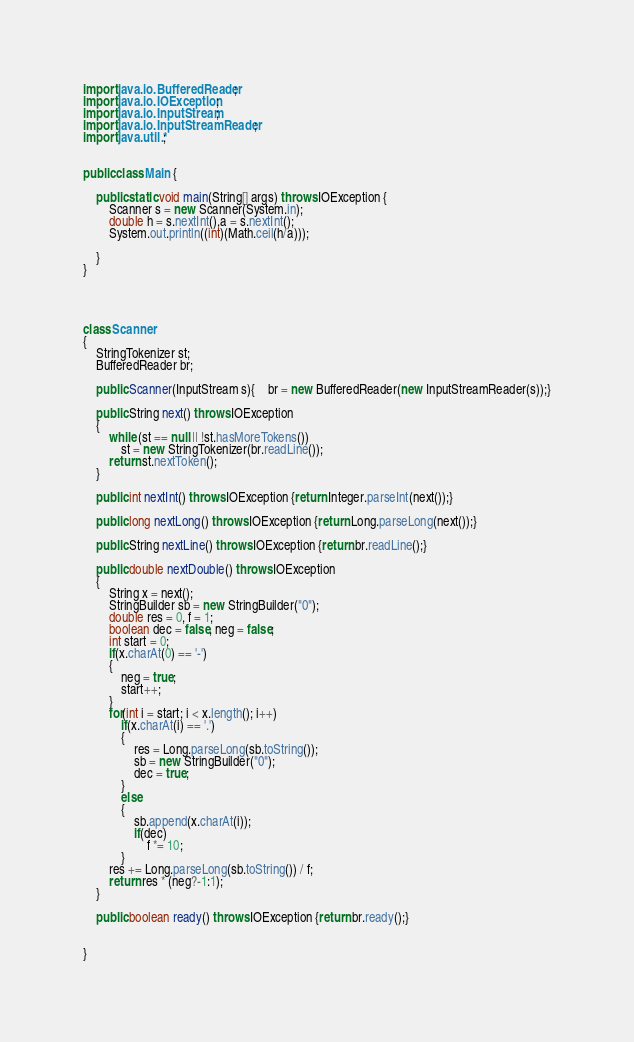<code> <loc_0><loc_0><loc_500><loc_500><_Java_>
import java.io.BufferedReader;
import java.io.IOException;
import java.io.InputStream;
import java.io.InputStreamReader;
import java.util.*;


public class Main {

    public static void main(String[] args) throws IOException {
        Scanner s = new Scanner(System.in);
        double h = s.nextInt(),a = s.nextInt();
        System.out.println((int)(Math.ceil(h/a)));

    }
}




class Scanner
{
    StringTokenizer st;
    BufferedReader br;

    public Scanner(InputStream s){	br = new BufferedReader(new InputStreamReader(s));}

    public String next() throws IOException
    {
        while (st == null || !st.hasMoreTokens())
            st = new StringTokenizer(br.readLine());
        return st.nextToken();
    }

    public int nextInt() throws IOException {return Integer.parseInt(next());}

    public long nextLong() throws IOException {return Long.parseLong(next());}

    public String nextLine() throws IOException {return br.readLine();}

    public double nextDouble() throws IOException
    {
        String x = next();
        StringBuilder sb = new StringBuilder("0");
        double res = 0, f = 1;
        boolean dec = false, neg = false;
        int start = 0;
        if(x.charAt(0) == '-')
        {
            neg = true;
            start++;
        }
        for(int i = start; i < x.length(); i++)
            if(x.charAt(i) == '.')
            {
                res = Long.parseLong(sb.toString());
                sb = new StringBuilder("0");
                dec = true;
            }
            else
            {
                sb.append(x.charAt(i));
                if(dec)
                    f *= 10;
            }
        res += Long.parseLong(sb.toString()) / f;
        return res * (neg?-1:1);
    }

    public boolean ready() throws IOException {return br.ready();}


}</code> 